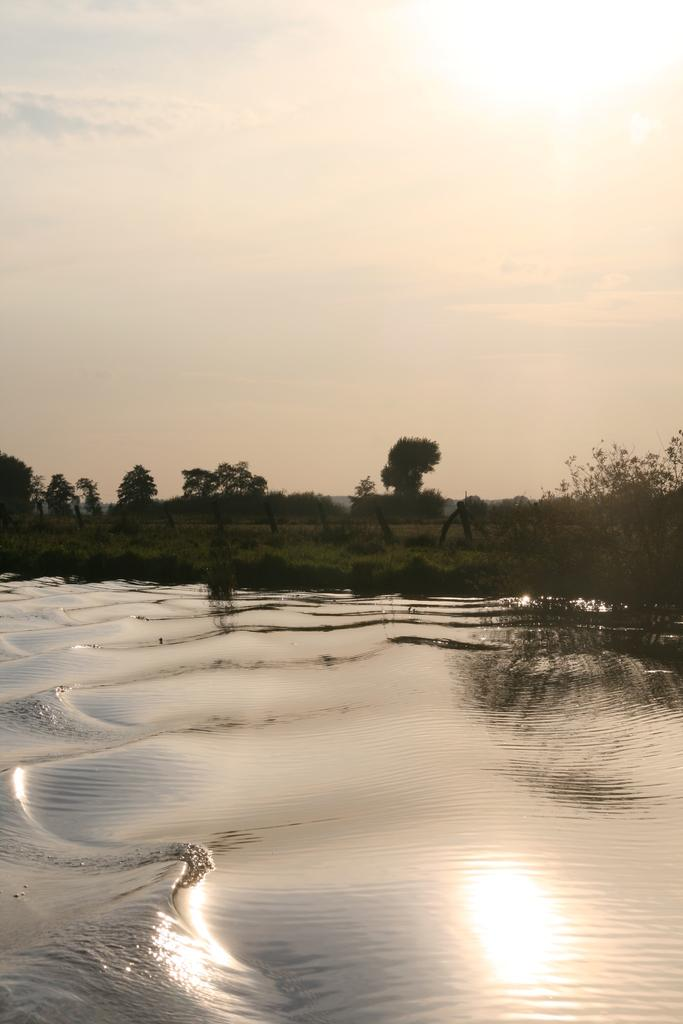What natural element can be seen in the image? Water is visible in the image. What type of vegetation is present in the image? There is grass and trees in the image. What is visible in the background of the image? The sky is visible in the background of the image. How many sheep can be seen grazing in the grass in the image? There are no sheep present in the image; it features water, grass, trees, and the sky. What type of drink is being consumed by the trees in the image? Trees do not consume drinks, and there are no drinks visible in the image. 